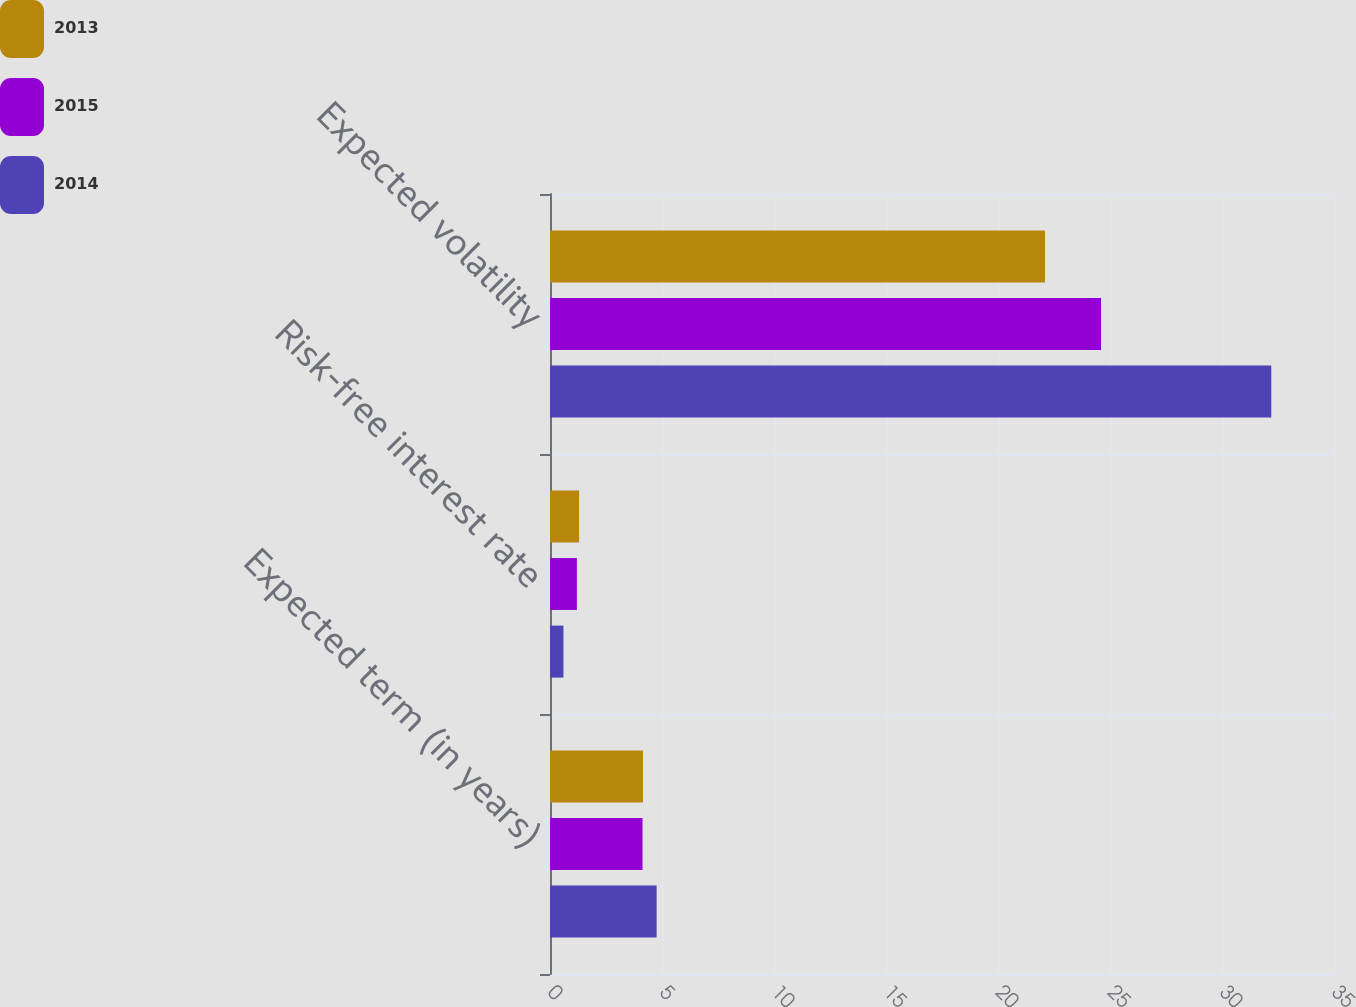<chart> <loc_0><loc_0><loc_500><loc_500><stacked_bar_chart><ecel><fcel>Expected term (in years)<fcel>Risk-free interest rate<fcel>Expected volatility<nl><fcel>2013<fcel>4.15<fcel>1.3<fcel>22.1<nl><fcel>2015<fcel>4.13<fcel>1.2<fcel>24.6<nl><fcel>2014<fcel>4.76<fcel>0.6<fcel>32.2<nl></chart> 